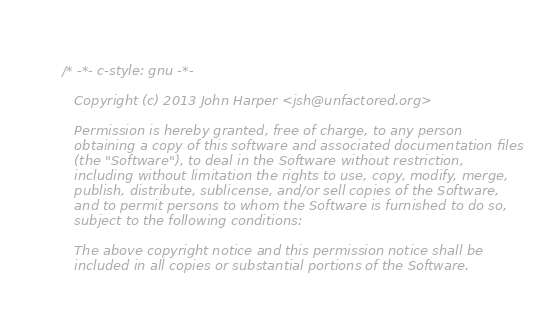<code> <loc_0><loc_0><loc_500><loc_500><_ObjectiveC_>/* -*- c-style: gnu -*-

   Copyright (c) 2013 John Harper <jsh@unfactored.org>

   Permission is hereby granted, free of charge, to any person
   obtaining a copy of this software and associated documentation files
   (the "Software"), to deal in the Software without restriction,
   including without limitation the rights to use, copy, modify, merge,
   publish, distribute, sublicense, and/or sell copies of the Software,
   and to permit persons to whom the Software is furnished to do so,
   subject to the following conditions:

   The above copyright notice and this permission notice shall be
   included in all copies or substantial portions of the Software.
</code> 